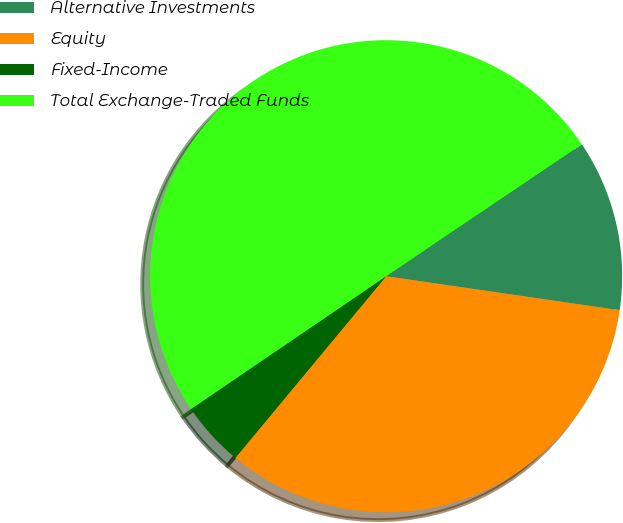<chart> <loc_0><loc_0><loc_500><loc_500><pie_chart><fcel>Alternative Investments<fcel>Equity<fcel>Fixed-Income<fcel>Total Exchange-Traded Funds<nl><fcel>11.74%<fcel>33.73%<fcel>4.46%<fcel>50.07%<nl></chart> 